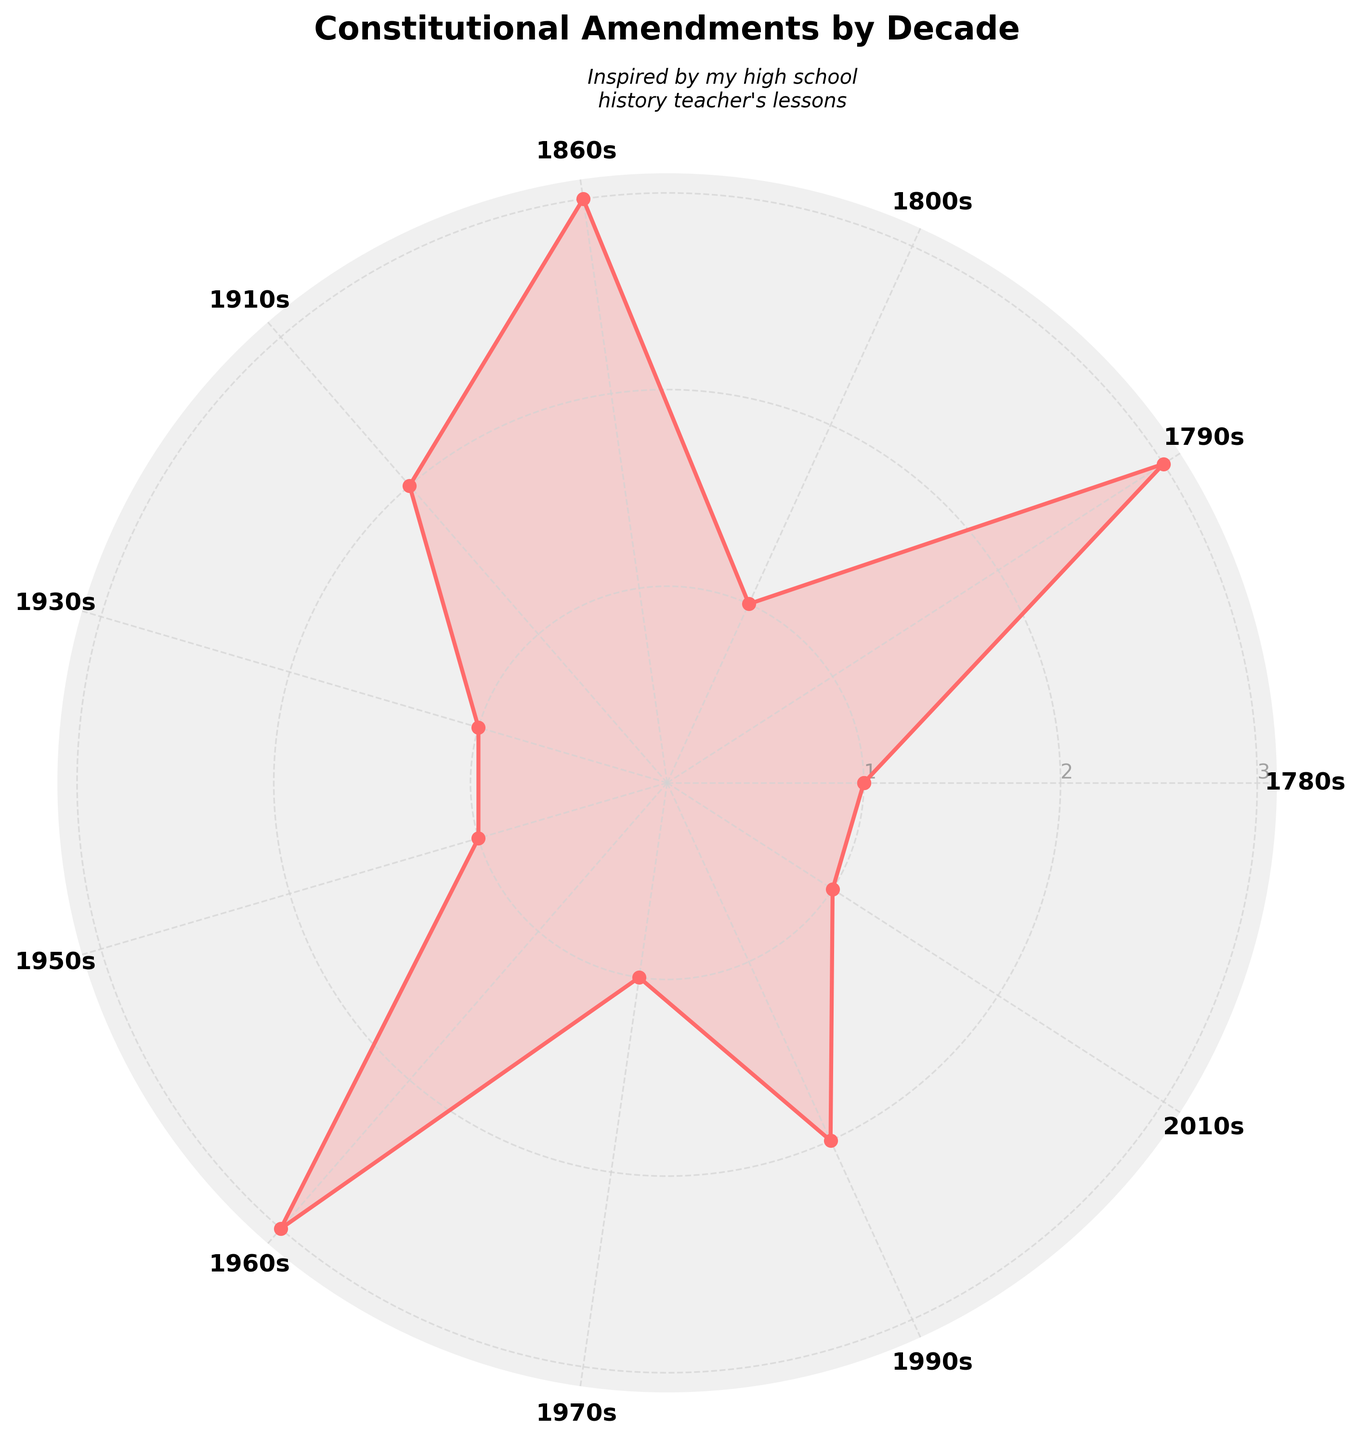What is the title of the figure? The title is usually placed at the top of the figure. In this case, it reads "Constitutional Amendments by Decade."
Answer: Constitutional Amendments by Decade How many decades are represented in the chart? Count the number of distinct categories or labels around the chart. The labels represent the decades.
Answer: 11 Which decade has the highest amendment count? Look for the largest value in the chart and identify its corresponding decade.
Answer: 1790s How many amendments were made in the 1960s? Locate the label for the 1960s and observe the value on the radial axis.
Answer: 3 What is the total number of amendments across all decades? Sum the values for each decade. The values are 1, 3, 1, 3, 2, 1, 1, 3, 1, 2, 1. Adding these gives 19.
Answer: 19 Compare the number of amendments made in the 1860s and the 1910s. Which one is higher? Locate the values for the 1860s and the 1910s. Compare these values. The 1860s has 3 amendments while the 1910s has 2.
Answer: 1860s Calculate the average number of amendments per decade. First, find the total number of amendments, which is 19. Then, divide by the number of decades, which is 11. So, 19 divided by 11 is approximately 1.73.
Answer: 1.73 Which decade(s) have exactly one amendment? Identify the categories with a value of 1 on the chart. These are the 1780s, 1800s, 1930s, 1950s, 1970s, and 2010s.
Answer: 1780s, 1800s, 1930s, 1950s, 1970s, 2010s How many decades saw at least two amendments? Count the number of labels on the chart with values of 2 or more. These are the 1790s, 1860s, 1910s, 1960s, and 1990s, totaling 5.
Answer: 5 What is the angle between the labels for the 1790s and the 1860s? Each category is equally spaced around the circle. Since there are 11 categories, the angle between adjacent categories is 360° / 11. The number of steps between the 1790s and the 1860s is 2. The angle is 2 * (360° / 11) ≈ 65.45°.
Answer: ~65.45° 